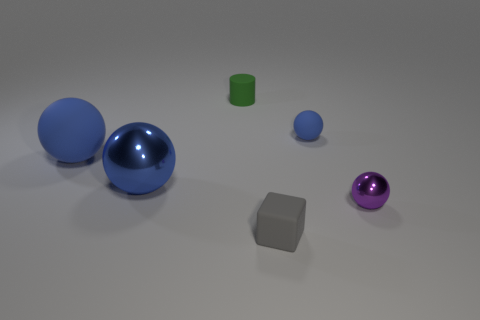What size is the other rubber sphere that is the same color as the small matte sphere?
Your answer should be compact. Large. How many other things are the same color as the large metal object?
Offer a very short reply. 2. There is a cylinder that is behind the shiny ball on the right side of the blue rubber thing right of the tiny gray matte block; what is its size?
Provide a short and direct response. Small. Is the color of the rubber sphere that is in front of the tiny blue thing the same as the big metal ball?
Make the answer very short. Yes. How many other objects are the same size as the gray matte thing?
Provide a succinct answer. 3. There is a blue sphere right of the small rubber thing in front of the tiny purple metal sphere that is in front of the large blue shiny thing; what is its material?
Provide a short and direct response. Rubber. What material is the big sphere that is the same color as the large matte object?
Give a very brief answer. Metal. What number of tiny blue objects have the same material as the small cylinder?
Make the answer very short. 1. Is the size of the metal sphere on the right side of the green object the same as the tiny matte block?
Provide a succinct answer. Yes. What is the color of the big sphere that is the same material as the purple thing?
Your response must be concise. Blue. 